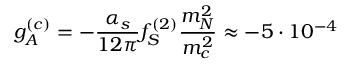Convert formula to latex. <formula><loc_0><loc_0><loc_500><loc_500>g _ { A } ^ { ( c ) } = - \frac { \alpha _ { s } } { 1 2 \pi } f _ { S } ^ { ( 2 ) } \frac { m _ { N } ^ { 2 } } { m _ { c } ^ { 2 } } \approx - 5 \cdot 1 0 ^ { - 4 }</formula> 